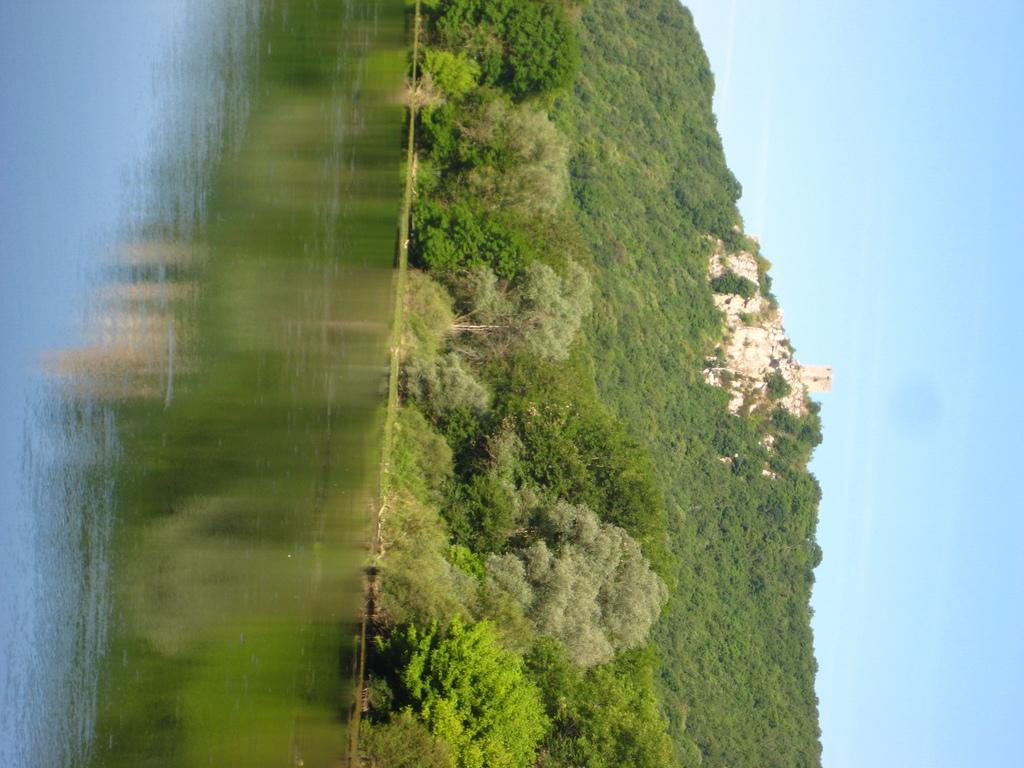What is one of the natural elements present in the image? There is water in the image. What type of vegetation can be seen in the image? There are trees in the image. What geographical feature is present in the image? There is a hill in the image. What is visible in the background of the image? The sky is visible in the image. What is being reflected on the water's surface? There is a reflection of trees on the water. How many eggs are visible on the hill in the image? There are no eggs present in the image. What type of bridge can be seen connecting the trees in the image? There is no bridge present in the image; it features water, trees, a hill, and the sky. 